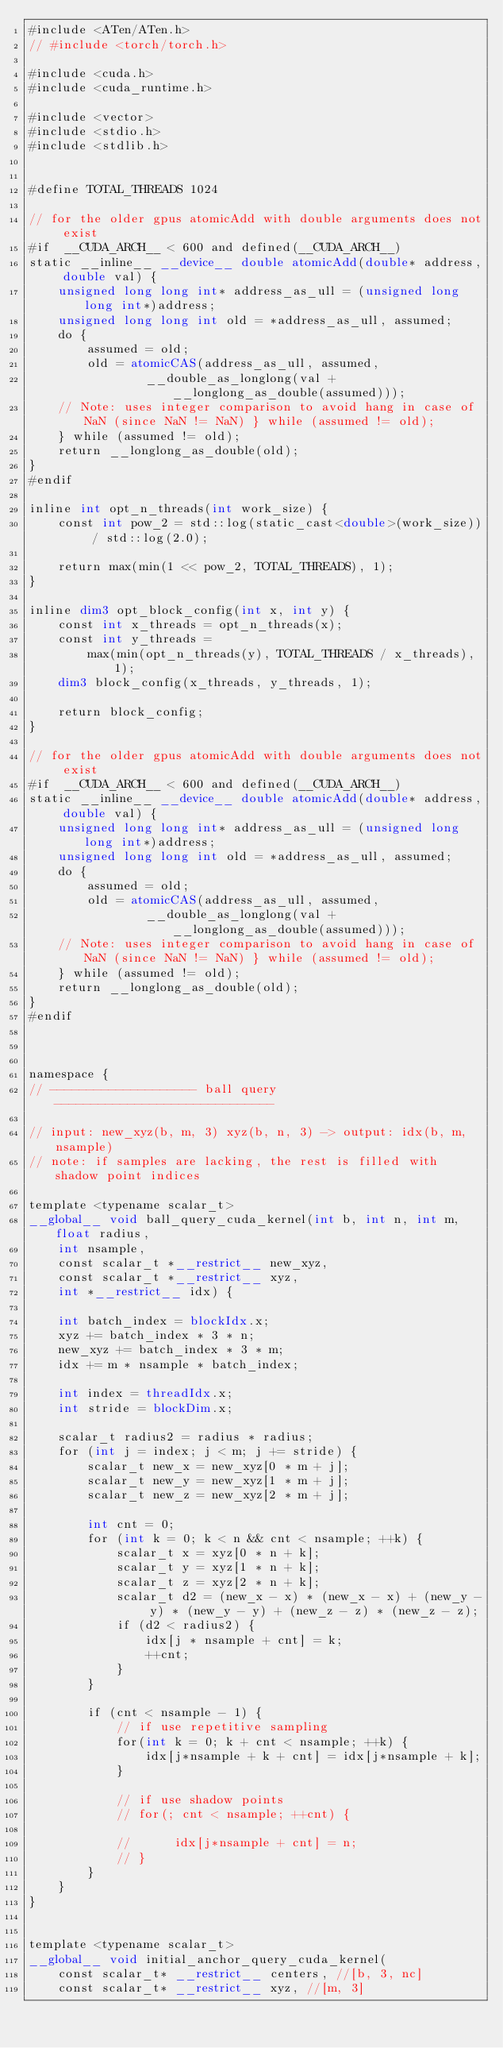<code> <loc_0><loc_0><loc_500><loc_500><_Cuda_>#include <ATen/ATen.h>
// #include <torch/torch.h>

#include <cuda.h>
#include <cuda_runtime.h>

#include <vector>
#include <stdio.h>
#include <stdlib.h>


#define TOTAL_THREADS 1024

// for the older gpus atomicAdd with double arguments does not exist
#if  __CUDA_ARCH__ < 600 and defined(__CUDA_ARCH__)
static __inline__ __device__ double atomicAdd(double* address, double val) {
    unsigned long long int* address_as_ull = (unsigned long long int*)address;
    unsigned long long int old = *address_as_ull, assumed;
    do {
        assumed = old;
        old = atomicCAS(address_as_ull, assumed,
                __double_as_longlong(val + __longlong_as_double(assumed)));
    // Note: uses integer comparison to avoid hang in case of NaN (since NaN != NaN) } while (assumed != old);
    } while (assumed != old);
    return __longlong_as_double(old);
}
#endif

inline int opt_n_threads(int work_size) {
    const int pow_2 = std::log(static_cast<double>(work_size)) / std::log(2.0);

    return max(min(1 << pow_2, TOTAL_THREADS), 1);
}

inline dim3 opt_block_config(int x, int y) {
    const int x_threads = opt_n_threads(x);
    const int y_threads =
        max(min(opt_n_threads(y), TOTAL_THREADS / x_threads), 1);
    dim3 block_config(x_threads, y_threads, 1);

    return block_config;
}

// for the older gpus atomicAdd with double arguments does not exist
#if  __CUDA_ARCH__ < 600 and defined(__CUDA_ARCH__)
static __inline__ __device__ double atomicAdd(double* address, double val) {
    unsigned long long int* address_as_ull = (unsigned long long int*)address;
    unsigned long long int old = *address_as_ull, assumed;
    do {
        assumed = old;
        old = atomicCAS(address_as_ull, assumed,
                __double_as_longlong(val + __longlong_as_double(assumed)));
    // Note: uses integer comparison to avoid hang in case of NaN (since NaN != NaN) } while (assumed != old);
    } while (assumed != old);
    return __longlong_as_double(old);
}
#endif



namespace {
// -------------------- ball query ------------------------------

// input: new_xyz(b, m, 3) xyz(b, n, 3) -> output: idx(b, m, nsample)
// note: if samples are lacking, the rest is filled with shadow point indices

template <typename scalar_t>
__global__ void ball_query_cuda_kernel(int b, int n, int m, float radius,
    int nsample,
    const scalar_t *__restrict__ new_xyz,
    const scalar_t *__restrict__ xyz,
    int *__restrict__ idx) {

    int batch_index = blockIdx.x;
    xyz += batch_index * 3 * n;
    new_xyz += batch_index * 3 * m;
    idx += m * nsample * batch_index;

    int index = threadIdx.x;
    int stride = blockDim.x;

    scalar_t radius2 = radius * radius;
    for (int j = index; j < m; j += stride) {
        scalar_t new_x = new_xyz[0 * m + j];
        scalar_t new_y = new_xyz[1 * m + j];
        scalar_t new_z = new_xyz[2 * m + j];

        int cnt = 0;
        for (int k = 0; k < n && cnt < nsample; ++k) {
            scalar_t x = xyz[0 * n + k];
            scalar_t y = xyz[1 * n + k];
            scalar_t z = xyz[2 * n + k];
            scalar_t d2 = (new_x - x) * (new_x - x) + (new_y - y) * (new_y - y) + (new_z - z) * (new_z - z);
            if (d2 < radius2) {
                idx[j * nsample + cnt] = k;
                ++cnt;
            }
        }

        if (cnt < nsample - 1) {
            // if use repetitive sampling
            for(int k = 0; k + cnt < nsample; ++k) {
                idx[j*nsample + k + cnt] = idx[j*nsample + k];
            }

            // if use shadow points
            // for(; cnt < nsample; ++cnt) {

            //      idx[j*nsample + cnt] = n;
            // }
        }
    }
}


template <typename scalar_t>
__global__ void initial_anchor_query_cuda_kernel(
    const scalar_t* __restrict__ centers, //[b, 3, nc]
    const scalar_t* __restrict__ xyz, //[m, 3]</code> 